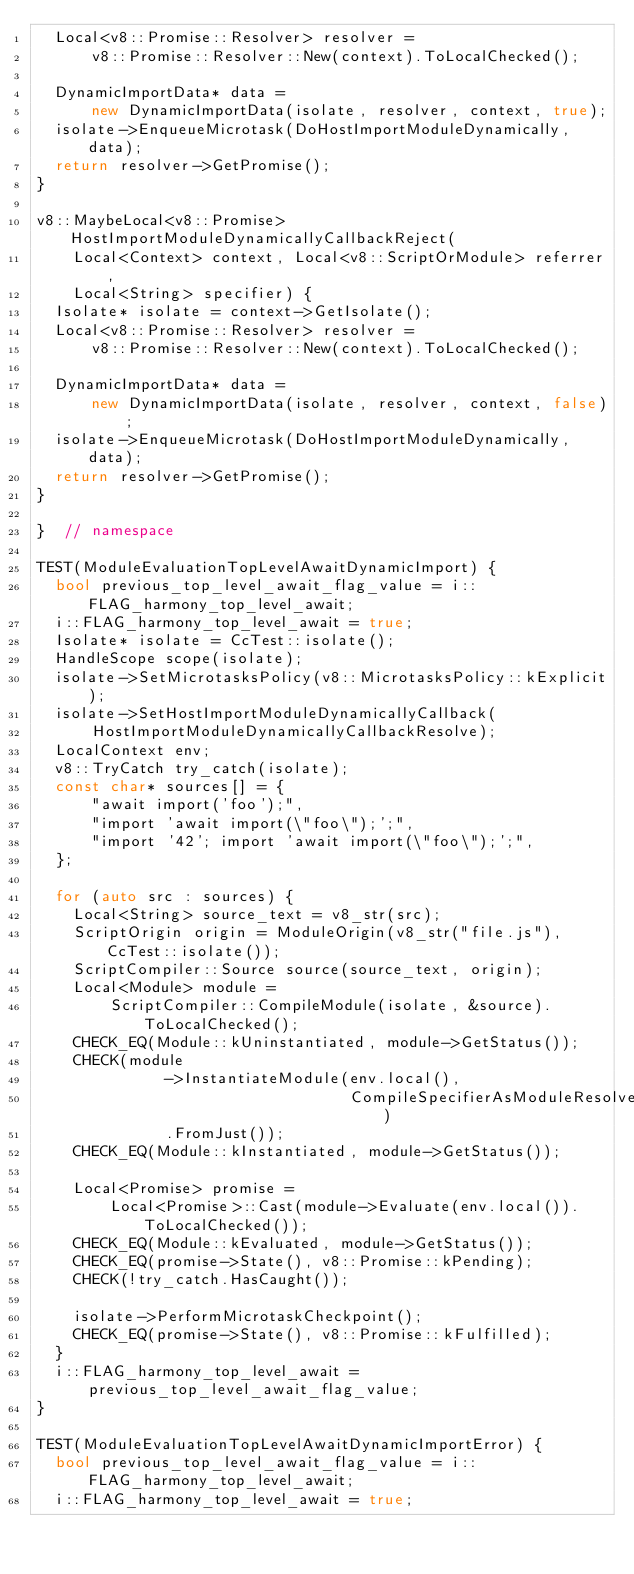<code> <loc_0><loc_0><loc_500><loc_500><_C++_>  Local<v8::Promise::Resolver> resolver =
      v8::Promise::Resolver::New(context).ToLocalChecked();

  DynamicImportData* data =
      new DynamicImportData(isolate, resolver, context, true);
  isolate->EnqueueMicrotask(DoHostImportModuleDynamically, data);
  return resolver->GetPromise();
}

v8::MaybeLocal<v8::Promise> HostImportModuleDynamicallyCallbackReject(
    Local<Context> context, Local<v8::ScriptOrModule> referrer,
    Local<String> specifier) {
  Isolate* isolate = context->GetIsolate();
  Local<v8::Promise::Resolver> resolver =
      v8::Promise::Resolver::New(context).ToLocalChecked();

  DynamicImportData* data =
      new DynamicImportData(isolate, resolver, context, false);
  isolate->EnqueueMicrotask(DoHostImportModuleDynamically, data);
  return resolver->GetPromise();
}

}  // namespace

TEST(ModuleEvaluationTopLevelAwaitDynamicImport) {
  bool previous_top_level_await_flag_value = i::FLAG_harmony_top_level_await;
  i::FLAG_harmony_top_level_await = true;
  Isolate* isolate = CcTest::isolate();
  HandleScope scope(isolate);
  isolate->SetMicrotasksPolicy(v8::MicrotasksPolicy::kExplicit);
  isolate->SetHostImportModuleDynamicallyCallback(
      HostImportModuleDynamicallyCallbackResolve);
  LocalContext env;
  v8::TryCatch try_catch(isolate);
  const char* sources[] = {
      "await import('foo');",
      "import 'await import(\"foo\");';",
      "import '42'; import 'await import(\"foo\");';",
  };

  for (auto src : sources) {
    Local<String> source_text = v8_str(src);
    ScriptOrigin origin = ModuleOrigin(v8_str("file.js"), CcTest::isolate());
    ScriptCompiler::Source source(source_text, origin);
    Local<Module> module =
        ScriptCompiler::CompileModule(isolate, &source).ToLocalChecked();
    CHECK_EQ(Module::kUninstantiated, module->GetStatus());
    CHECK(module
              ->InstantiateModule(env.local(),
                                  CompileSpecifierAsModuleResolveCallback)
              .FromJust());
    CHECK_EQ(Module::kInstantiated, module->GetStatus());

    Local<Promise> promise =
        Local<Promise>::Cast(module->Evaluate(env.local()).ToLocalChecked());
    CHECK_EQ(Module::kEvaluated, module->GetStatus());
    CHECK_EQ(promise->State(), v8::Promise::kPending);
    CHECK(!try_catch.HasCaught());

    isolate->PerformMicrotaskCheckpoint();
    CHECK_EQ(promise->State(), v8::Promise::kFulfilled);
  }
  i::FLAG_harmony_top_level_await = previous_top_level_await_flag_value;
}

TEST(ModuleEvaluationTopLevelAwaitDynamicImportError) {
  bool previous_top_level_await_flag_value = i::FLAG_harmony_top_level_await;
  i::FLAG_harmony_top_level_await = true;</code> 